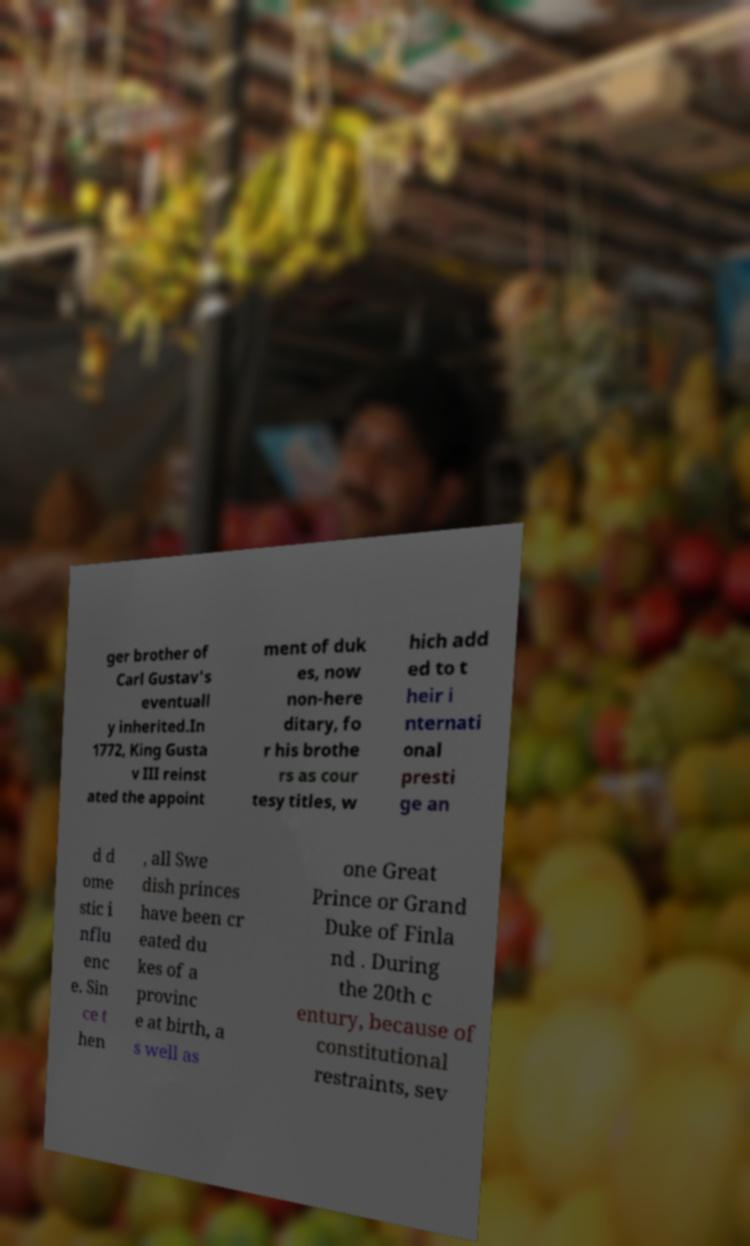Can you accurately transcribe the text from the provided image for me? ger brother of Carl Gustav's eventuall y inherited.In 1772, King Gusta v III reinst ated the appoint ment of duk es, now non-here ditary, fo r his brothe rs as cour tesy titles, w hich add ed to t heir i nternati onal presti ge an d d ome stic i nflu enc e. Sin ce t hen , all Swe dish princes have been cr eated du kes of a provinc e at birth, a s well as one Great Prince or Grand Duke of Finla nd . During the 20th c entury, because of constitutional restraints, sev 